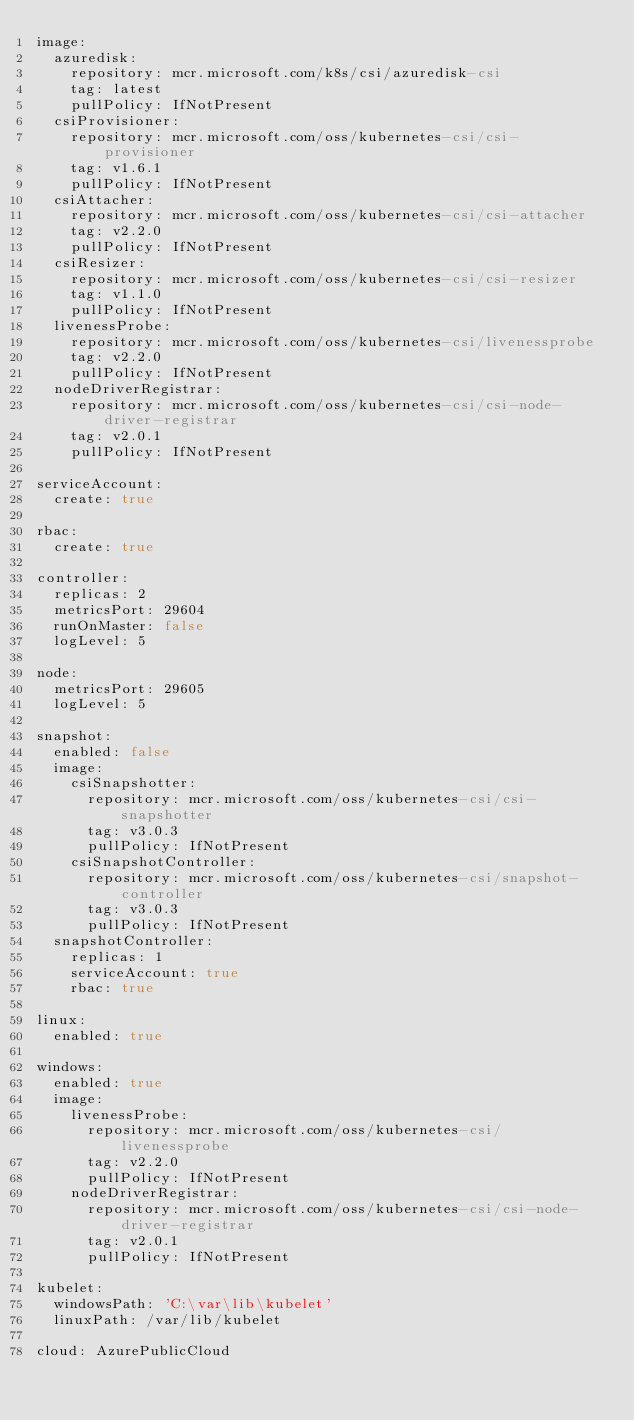Convert code to text. <code><loc_0><loc_0><loc_500><loc_500><_YAML_>image:
  azuredisk:
    repository: mcr.microsoft.com/k8s/csi/azuredisk-csi
    tag: latest
    pullPolicy: IfNotPresent
  csiProvisioner:
    repository: mcr.microsoft.com/oss/kubernetes-csi/csi-provisioner
    tag: v1.6.1
    pullPolicy: IfNotPresent
  csiAttacher:
    repository: mcr.microsoft.com/oss/kubernetes-csi/csi-attacher
    tag: v2.2.0
    pullPolicy: IfNotPresent
  csiResizer:
    repository: mcr.microsoft.com/oss/kubernetes-csi/csi-resizer
    tag: v1.1.0
    pullPolicy: IfNotPresent
  livenessProbe:
    repository: mcr.microsoft.com/oss/kubernetes-csi/livenessprobe
    tag: v2.2.0
    pullPolicy: IfNotPresent
  nodeDriverRegistrar:
    repository: mcr.microsoft.com/oss/kubernetes-csi/csi-node-driver-registrar
    tag: v2.0.1
    pullPolicy: IfNotPresent

serviceAccount:
  create: true

rbac:
  create: true

controller:
  replicas: 2
  metricsPort: 29604
  runOnMaster: false
  logLevel: 5

node:
  metricsPort: 29605
  logLevel: 5

snapshot:
  enabled: false
  image:
    csiSnapshotter:
      repository: mcr.microsoft.com/oss/kubernetes-csi/csi-snapshotter
      tag: v3.0.3
      pullPolicy: IfNotPresent
    csiSnapshotController:
      repository: mcr.microsoft.com/oss/kubernetes-csi/snapshot-controller
      tag: v3.0.3
      pullPolicy: IfNotPresent
  snapshotController:
    replicas: 1
    serviceAccount: true
    rbac: true

linux:
  enabled: true

windows:
  enabled: true
  image:
    livenessProbe:
      repository: mcr.microsoft.com/oss/kubernetes-csi/livenessprobe
      tag: v2.2.0
      pullPolicy: IfNotPresent
    nodeDriverRegistrar:
      repository: mcr.microsoft.com/oss/kubernetes-csi/csi-node-driver-registrar
      tag: v2.0.1
      pullPolicy: IfNotPresent

kubelet:
  windowsPath: 'C:\var\lib\kubelet'
  linuxPath: /var/lib/kubelet

cloud: AzurePublicCloud
</code> 